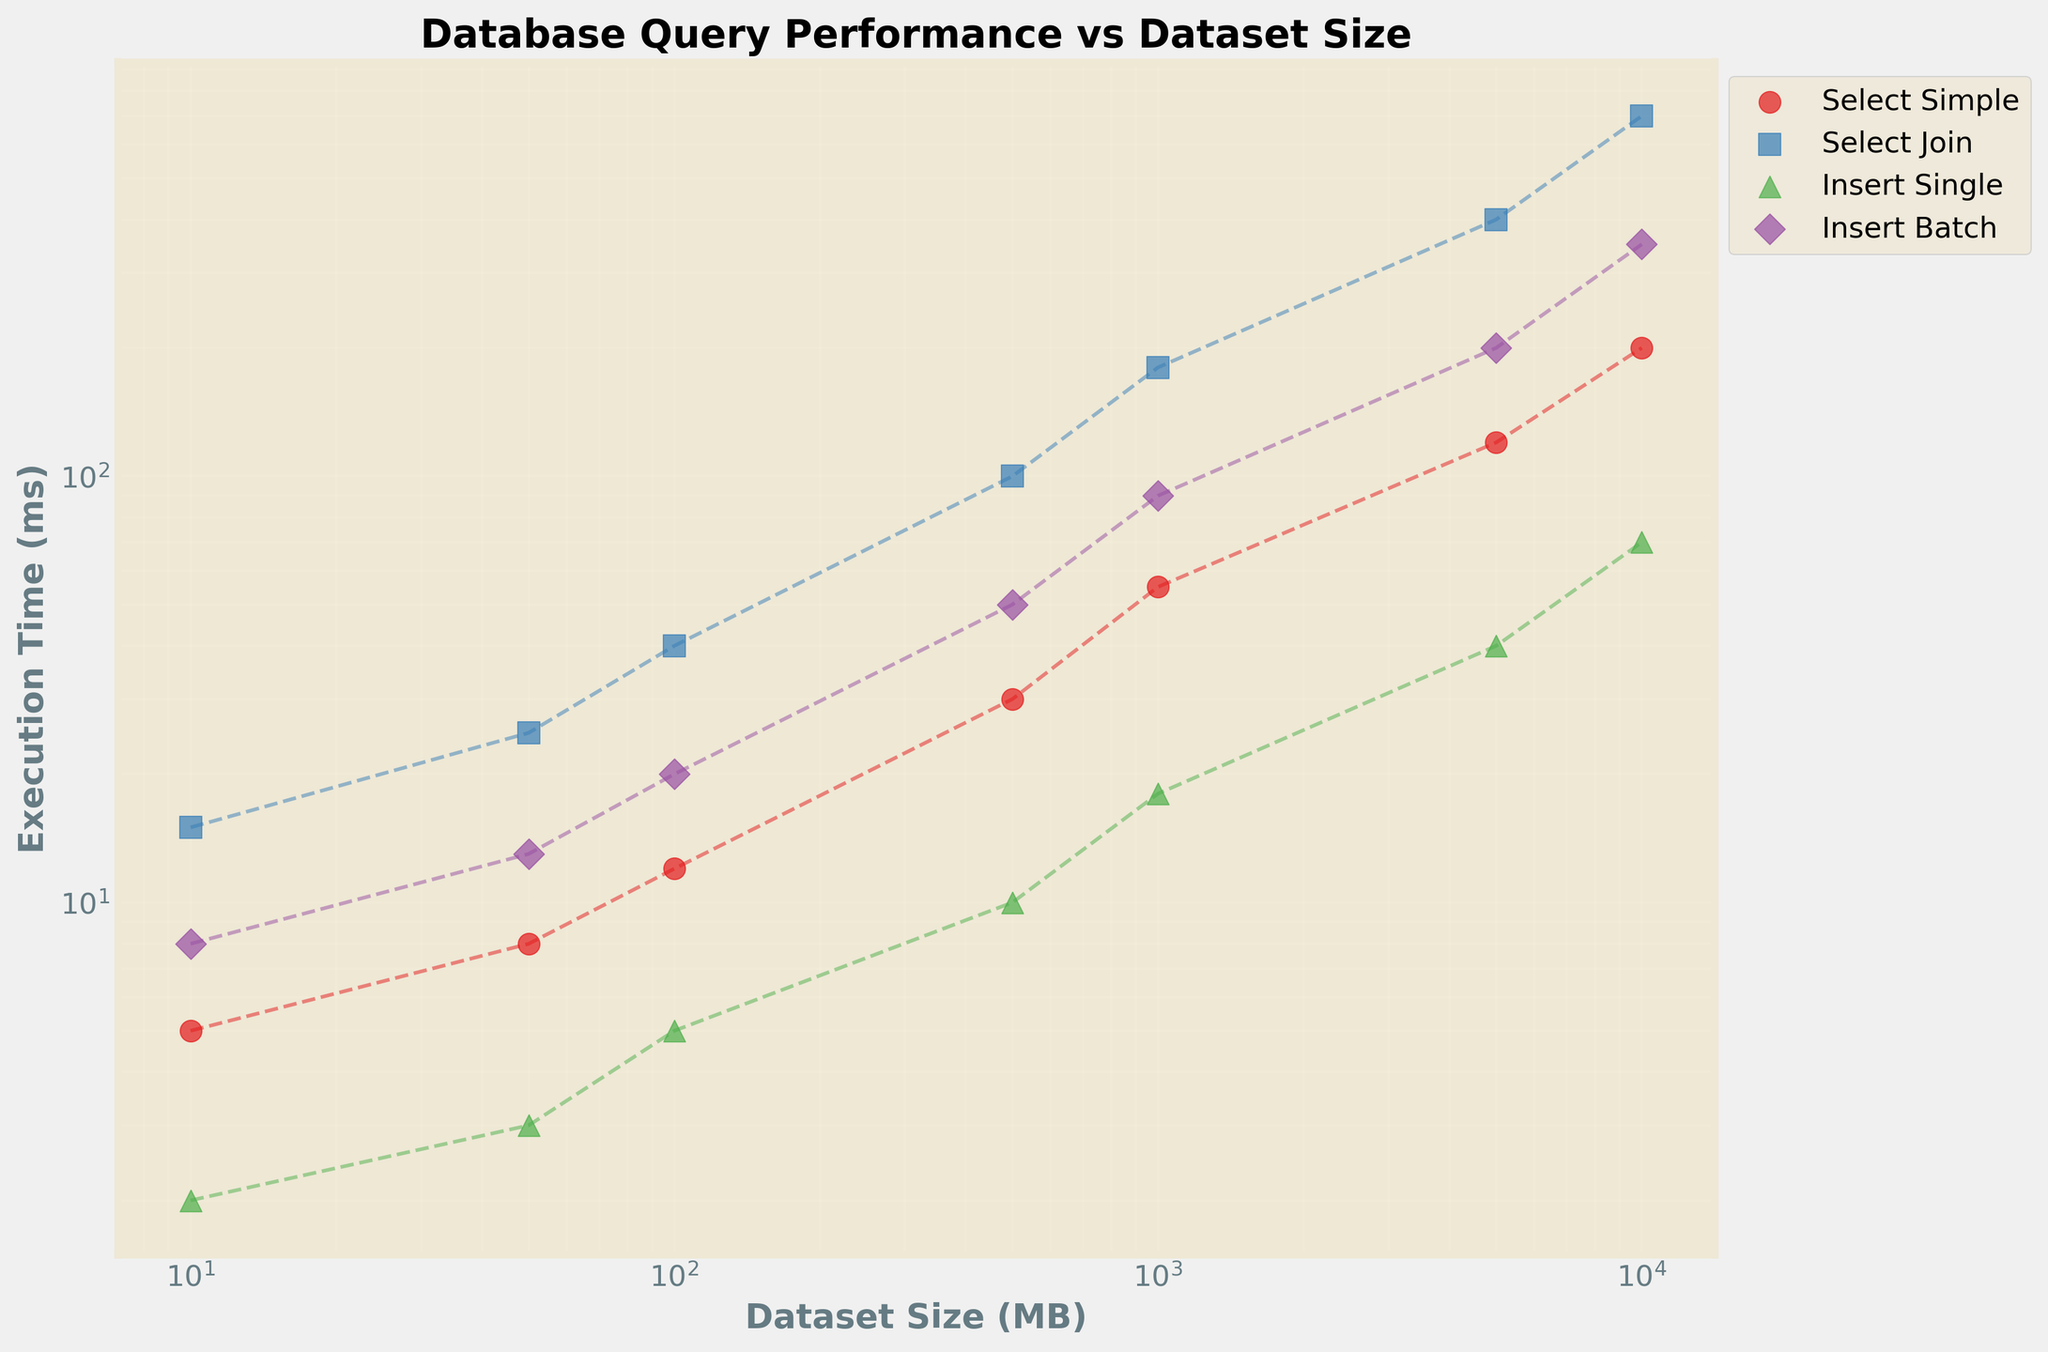What is the title of the plot? The title is the text at the top of the plot. It reads "Database Query Performance vs Dataset Size," indicating what the plot is about.
Answer: Database Query Performance vs Dataset Size What are the units of the x-axis? The x-axis title is "Dataset Size (MB)," meaning the units are megabytes (MB).
Answer: MB Which query type has the longest execution time for a dataset size of 1000 MB? By looking at the execution times on the y-axis for the x-axis value of 1000 MB, "Select Join" has the highest execution time. It's visibly higher compared to other query types.
Answer: Select Join How does the execution time of "Insert Single" queries compare at 50 MB and 500 MB? The execution time for 50 MB is 3 ms and for 500 MB is 10 ms. Comparing these values shows that the execution time increases as the dataset size increases.
Answer: Execution time increases What is the shape of the trend for the "Select Simple" query type? Observing the "Select Simple" path, it follows a roughly linear trend on the logarithmic scale, rising steadily as dataset sizes increase.
Answer: Linear increase Which query type shows the most significant increase in execution time from 1000 MB to 5000 MB? By examining the change in execution times between 1000 MB and 5000 MB for each query type, "Select Join" shows the most significant increase. It goes from 180 ms to 400 ms.
Answer: Select Join Are all axes on a logarithmic scale? Both the x-axis (Dataset Size) and y-axis (Execution Time) are on a logarithmic scale, as indicated by the plotted data and the axis labels.
Answer: Yes What is the execution time of "Insert Batch" at 10 MB? The subplot for "Insert Batch" at 10 MB shows an execution time of 8 ms, as indicated by the corresponding marker.
Answer: 8 ms Which query type has the least execution time at 10000 MB? Checking the execution times for all query types at 10000 MB, "Insert Single" has the least execution time with 70 ms.
Answer: Insert Single 